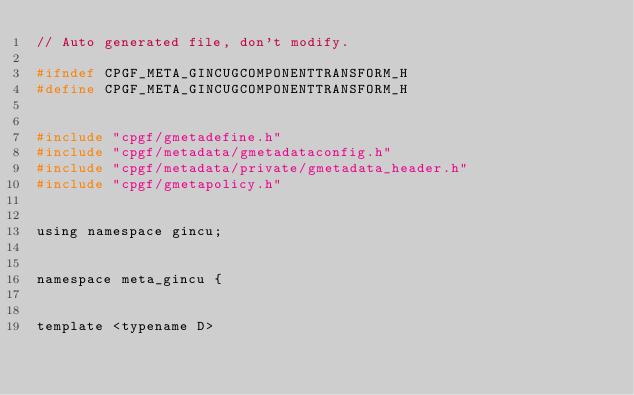<code> <loc_0><loc_0><loc_500><loc_500><_C_>// Auto generated file, don't modify.

#ifndef CPGF_META_GINCUGCOMPONENTTRANSFORM_H
#define CPGF_META_GINCUGCOMPONENTTRANSFORM_H


#include "cpgf/gmetadefine.h"
#include "cpgf/metadata/gmetadataconfig.h"
#include "cpgf/metadata/private/gmetadata_header.h"
#include "cpgf/gmetapolicy.h"


using namespace gincu;


namespace meta_gincu { 


template <typename D></code> 